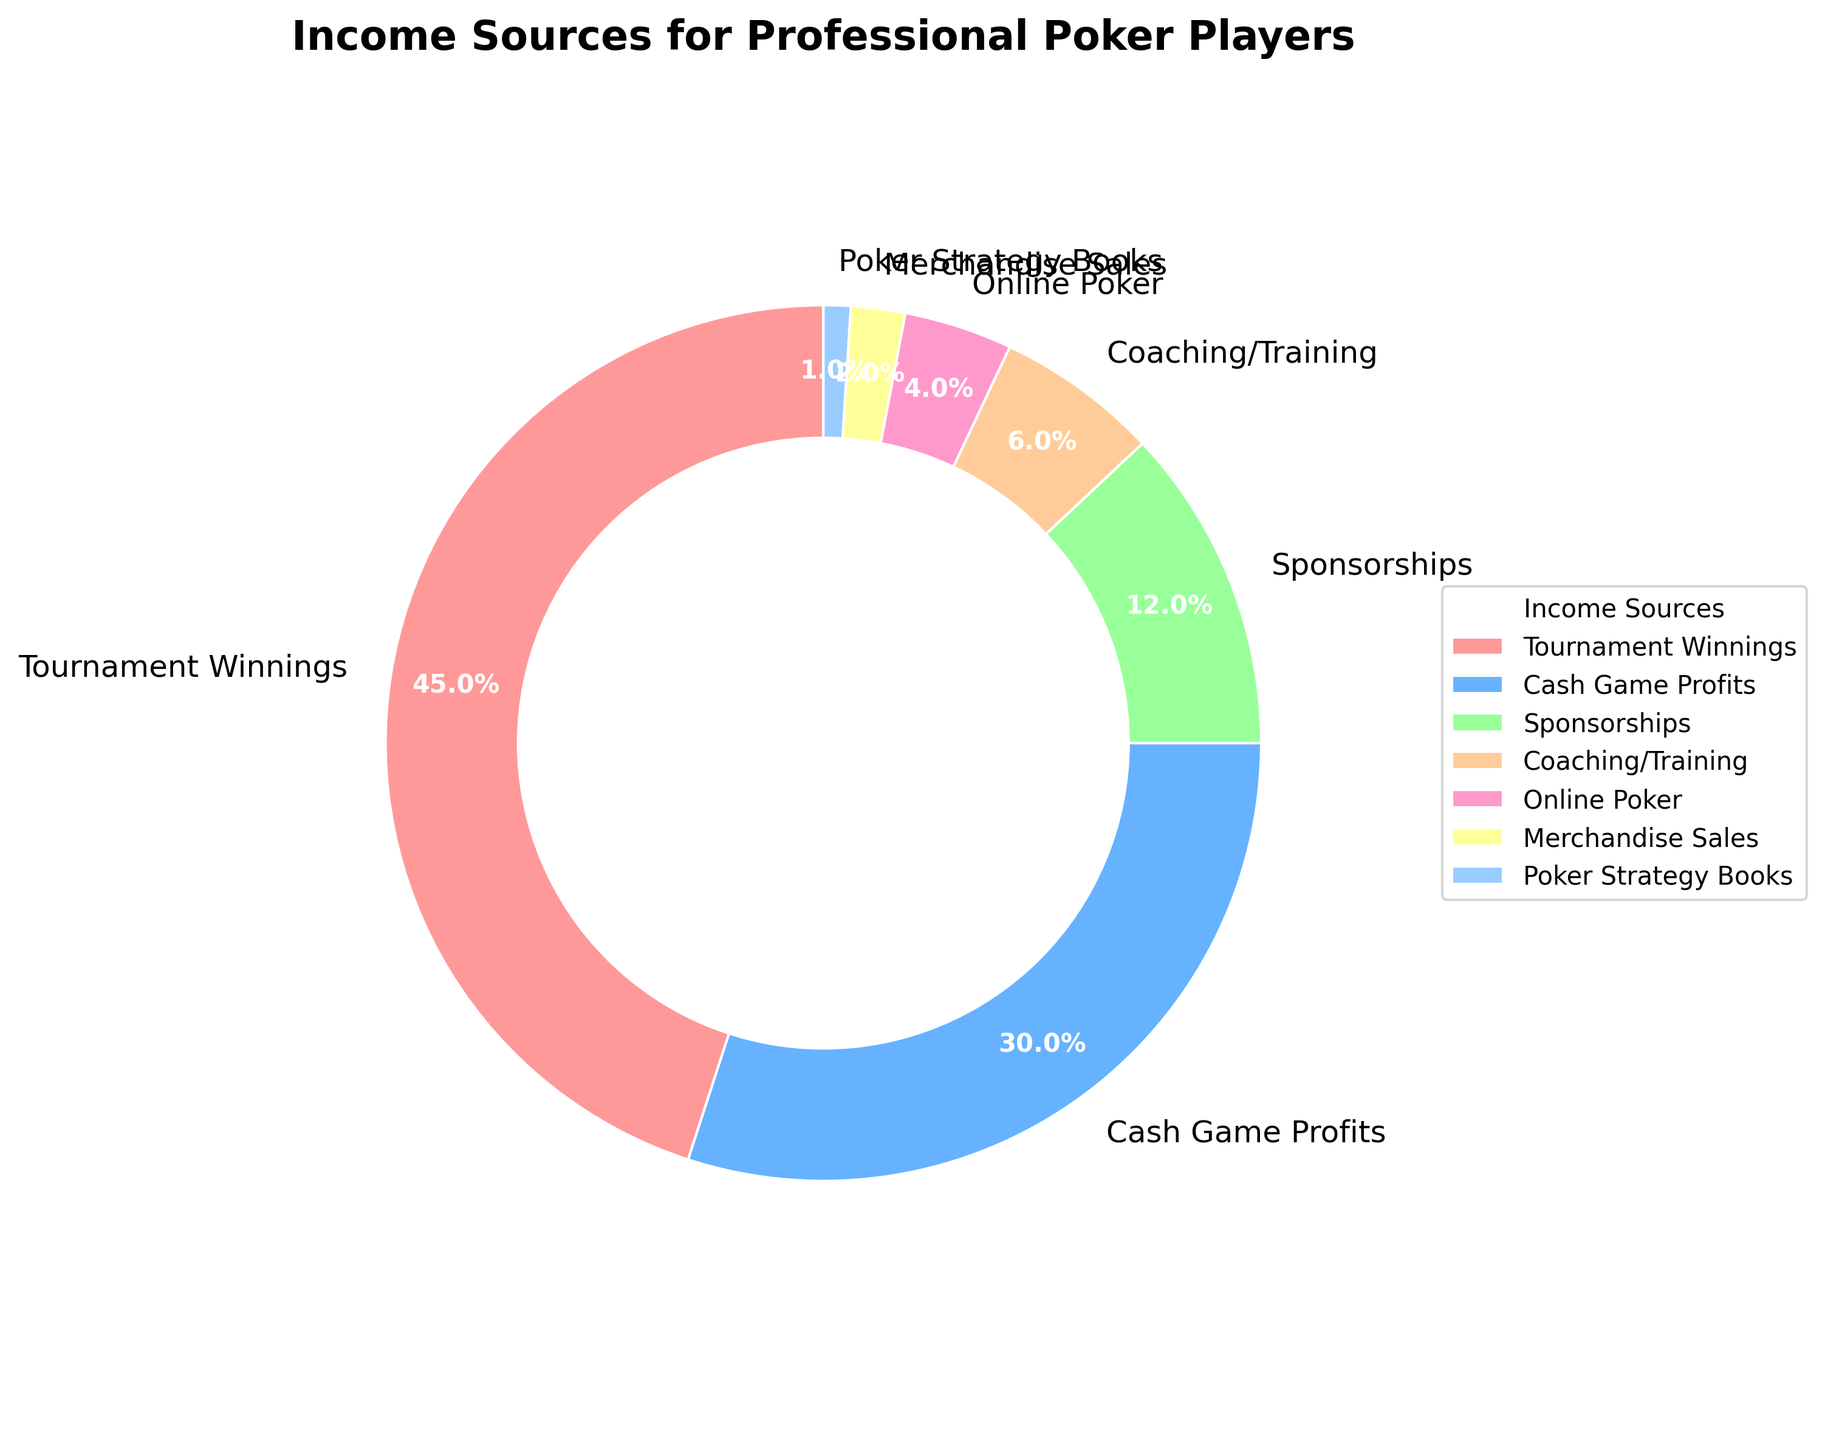What's the largest income source for professional poker players? The largest income source can be identified by looking for the biggest slice in the pie chart, which is labeled as "Tournament Winnings" with 45%.
Answer: Tournament Winnings What percentage of income comes from Cash Game Profits and Sponsorships combined? To find the combined percentage, add the proportion for Cash Game Profits (30%) and Sponsorships (12%): 30 + 12 = 42%.
Answer: 42% Which income source contributes less than 5% to the overall income? Identify the slices with less than 5%. Both "Online Poker" (4%) and "Merchandise Sales" (2%) have percentages under 5%.
Answer: Online Poker, Merchandise Sales Is the income from Coaching/Training greater or less than the income from Online Poker? Compare the percentages for Coaching/Training (6%) and Online Poker (4%). Since 6 > 4, Coaching/Training is greater.
Answer: Greater How much more does Tournament Winnings contribute compared to Sponsorships? Find the difference between the percentages of these two sources: 45% - 12% = 33%.
Answer: 33% What is the total percentage of the income sources contributing less than 10%? Sum the percentages of all sources less than 10%: Sponsorships (12%) isn't counted. So, total is Coaching/Training (6%) + Online Poker (4%) + Merchandise Sales (2%) + Poker Strategy Books (1%) = 13%.
Answer: 13% Which income source is represented by the blue color on the pie chart? The pie chart's visual key shows that the blue color corresponds to "Cash Game Profits".
Answer: Cash Game Profits Which two income sources have a combined contribution of the least percentage? Identify the two smallest slices and sum their percentages: Poker Strategy Books (1%) + Merchandise Sales (2%) = 3%.
Answer: Poker Strategy Books, Merchandise Sales 